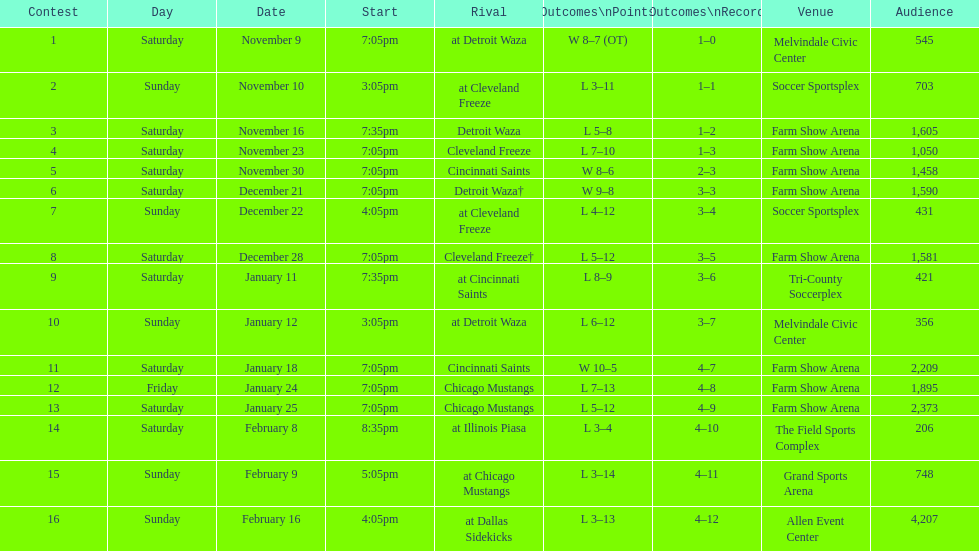What is the date of the game after december 22? December 28. 